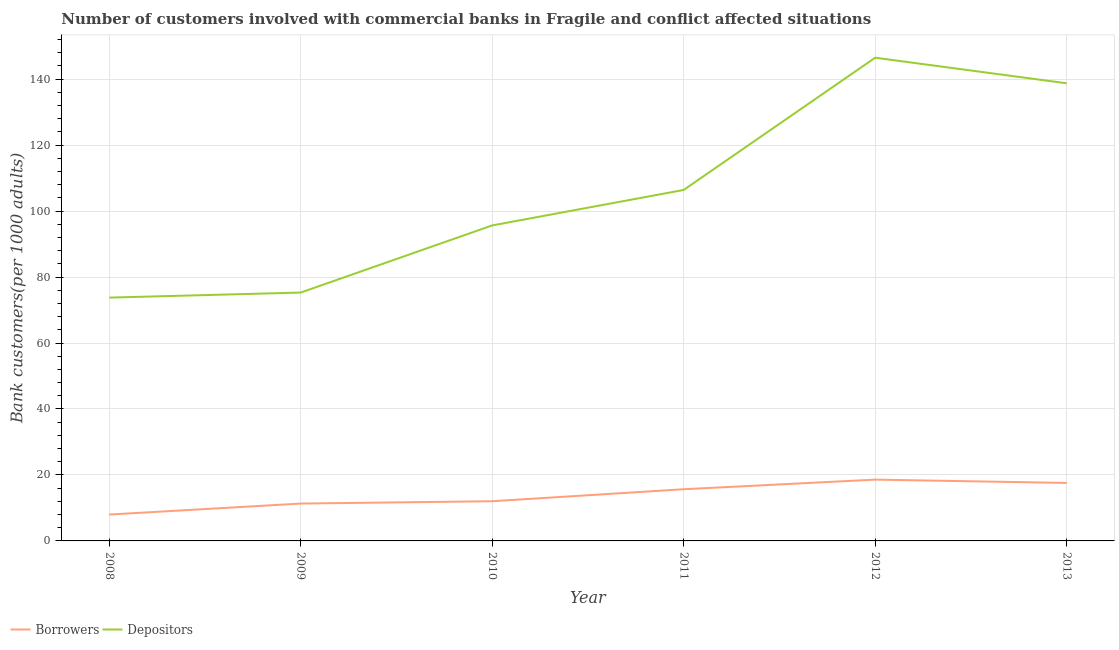How many different coloured lines are there?
Provide a short and direct response. 2. Does the line corresponding to number of borrowers intersect with the line corresponding to number of depositors?
Provide a short and direct response. No. Is the number of lines equal to the number of legend labels?
Your response must be concise. Yes. What is the number of depositors in 2011?
Your answer should be very brief. 106.41. Across all years, what is the maximum number of borrowers?
Provide a succinct answer. 18.58. Across all years, what is the minimum number of borrowers?
Make the answer very short. 7.99. In which year was the number of depositors minimum?
Make the answer very short. 2008. What is the total number of depositors in the graph?
Make the answer very short. 636.36. What is the difference between the number of borrowers in 2011 and that in 2013?
Ensure brevity in your answer.  -1.91. What is the difference between the number of borrowers in 2011 and the number of depositors in 2013?
Your answer should be compact. -123.07. What is the average number of depositors per year?
Offer a very short reply. 106.06. In the year 2013, what is the difference between the number of borrowers and number of depositors?
Your answer should be compact. -121.17. What is the ratio of the number of borrowers in 2012 to that in 2013?
Offer a very short reply. 1.06. Is the difference between the number of borrowers in 2009 and 2011 greater than the difference between the number of depositors in 2009 and 2011?
Offer a terse response. Yes. What is the difference between the highest and the second highest number of borrowers?
Your answer should be compact. 1. What is the difference between the highest and the lowest number of borrowers?
Offer a very short reply. 10.59. Is the sum of the number of depositors in 2008 and 2011 greater than the maximum number of borrowers across all years?
Keep it short and to the point. Yes. Is the number of borrowers strictly less than the number of depositors over the years?
Your answer should be very brief. Yes. How many years are there in the graph?
Offer a very short reply. 6. Does the graph contain any zero values?
Provide a succinct answer. No. Where does the legend appear in the graph?
Your answer should be very brief. Bottom left. How are the legend labels stacked?
Keep it short and to the point. Horizontal. What is the title of the graph?
Give a very brief answer. Number of customers involved with commercial banks in Fragile and conflict affected situations. What is the label or title of the X-axis?
Your answer should be very brief. Year. What is the label or title of the Y-axis?
Provide a succinct answer. Bank customers(per 1000 adults). What is the Bank customers(per 1000 adults) in Borrowers in 2008?
Your response must be concise. 7.99. What is the Bank customers(per 1000 adults) of Depositors in 2008?
Your answer should be very brief. 73.77. What is the Bank customers(per 1000 adults) in Borrowers in 2009?
Your answer should be compact. 11.33. What is the Bank customers(per 1000 adults) in Depositors in 2009?
Make the answer very short. 75.3. What is the Bank customers(per 1000 adults) of Borrowers in 2010?
Give a very brief answer. 12.03. What is the Bank customers(per 1000 adults) of Depositors in 2010?
Your answer should be very brief. 95.65. What is the Bank customers(per 1000 adults) in Borrowers in 2011?
Offer a terse response. 15.67. What is the Bank customers(per 1000 adults) of Depositors in 2011?
Make the answer very short. 106.41. What is the Bank customers(per 1000 adults) of Borrowers in 2012?
Your response must be concise. 18.58. What is the Bank customers(per 1000 adults) of Depositors in 2012?
Ensure brevity in your answer.  146.5. What is the Bank customers(per 1000 adults) of Borrowers in 2013?
Your answer should be very brief. 17.58. What is the Bank customers(per 1000 adults) of Depositors in 2013?
Keep it short and to the point. 138.74. Across all years, what is the maximum Bank customers(per 1000 adults) in Borrowers?
Your answer should be compact. 18.58. Across all years, what is the maximum Bank customers(per 1000 adults) in Depositors?
Offer a very short reply. 146.5. Across all years, what is the minimum Bank customers(per 1000 adults) in Borrowers?
Provide a short and direct response. 7.99. Across all years, what is the minimum Bank customers(per 1000 adults) in Depositors?
Give a very brief answer. 73.77. What is the total Bank customers(per 1000 adults) of Borrowers in the graph?
Provide a succinct answer. 83.18. What is the total Bank customers(per 1000 adults) of Depositors in the graph?
Keep it short and to the point. 636.36. What is the difference between the Bank customers(per 1000 adults) in Borrowers in 2008 and that in 2009?
Offer a terse response. -3.33. What is the difference between the Bank customers(per 1000 adults) in Depositors in 2008 and that in 2009?
Your answer should be compact. -1.53. What is the difference between the Bank customers(per 1000 adults) of Borrowers in 2008 and that in 2010?
Your response must be concise. -4.04. What is the difference between the Bank customers(per 1000 adults) of Depositors in 2008 and that in 2010?
Give a very brief answer. -21.88. What is the difference between the Bank customers(per 1000 adults) of Borrowers in 2008 and that in 2011?
Offer a terse response. -7.68. What is the difference between the Bank customers(per 1000 adults) in Depositors in 2008 and that in 2011?
Offer a very short reply. -32.64. What is the difference between the Bank customers(per 1000 adults) in Borrowers in 2008 and that in 2012?
Give a very brief answer. -10.59. What is the difference between the Bank customers(per 1000 adults) in Depositors in 2008 and that in 2012?
Your answer should be compact. -72.73. What is the difference between the Bank customers(per 1000 adults) of Borrowers in 2008 and that in 2013?
Offer a very short reply. -9.58. What is the difference between the Bank customers(per 1000 adults) in Depositors in 2008 and that in 2013?
Your answer should be compact. -64.97. What is the difference between the Bank customers(per 1000 adults) in Borrowers in 2009 and that in 2010?
Offer a very short reply. -0.7. What is the difference between the Bank customers(per 1000 adults) of Depositors in 2009 and that in 2010?
Provide a succinct answer. -20.35. What is the difference between the Bank customers(per 1000 adults) in Borrowers in 2009 and that in 2011?
Your answer should be compact. -4.34. What is the difference between the Bank customers(per 1000 adults) of Depositors in 2009 and that in 2011?
Your response must be concise. -31.11. What is the difference between the Bank customers(per 1000 adults) in Borrowers in 2009 and that in 2012?
Provide a short and direct response. -7.25. What is the difference between the Bank customers(per 1000 adults) in Depositors in 2009 and that in 2012?
Make the answer very short. -71.2. What is the difference between the Bank customers(per 1000 adults) in Borrowers in 2009 and that in 2013?
Provide a succinct answer. -6.25. What is the difference between the Bank customers(per 1000 adults) of Depositors in 2009 and that in 2013?
Keep it short and to the point. -63.44. What is the difference between the Bank customers(per 1000 adults) in Borrowers in 2010 and that in 2011?
Offer a terse response. -3.64. What is the difference between the Bank customers(per 1000 adults) of Depositors in 2010 and that in 2011?
Provide a short and direct response. -10.75. What is the difference between the Bank customers(per 1000 adults) in Borrowers in 2010 and that in 2012?
Provide a succinct answer. -6.55. What is the difference between the Bank customers(per 1000 adults) of Depositors in 2010 and that in 2012?
Ensure brevity in your answer.  -50.84. What is the difference between the Bank customers(per 1000 adults) in Borrowers in 2010 and that in 2013?
Your response must be concise. -5.55. What is the difference between the Bank customers(per 1000 adults) in Depositors in 2010 and that in 2013?
Keep it short and to the point. -43.09. What is the difference between the Bank customers(per 1000 adults) in Borrowers in 2011 and that in 2012?
Ensure brevity in your answer.  -2.91. What is the difference between the Bank customers(per 1000 adults) in Depositors in 2011 and that in 2012?
Provide a succinct answer. -40.09. What is the difference between the Bank customers(per 1000 adults) of Borrowers in 2011 and that in 2013?
Ensure brevity in your answer.  -1.91. What is the difference between the Bank customers(per 1000 adults) of Depositors in 2011 and that in 2013?
Your answer should be compact. -32.34. What is the difference between the Bank customers(per 1000 adults) of Borrowers in 2012 and that in 2013?
Offer a very short reply. 1. What is the difference between the Bank customers(per 1000 adults) in Depositors in 2012 and that in 2013?
Offer a very short reply. 7.75. What is the difference between the Bank customers(per 1000 adults) of Borrowers in 2008 and the Bank customers(per 1000 adults) of Depositors in 2009?
Your response must be concise. -67.31. What is the difference between the Bank customers(per 1000 adults) of Borrowers in 2008 and the Bank customers(per 1000 adults) of Depositors in 2010?
Your response must be concise. -87.66. What is the difference between the Bank customers(per 1000 adults) in Borrowers in 2008 and the Bank customers(per 1000 adults) in Depositors in 2011?
Your answer should be very brief. -98.41. What is the difference between the Bank customers(per 1000 adults) of Borrowers in 2008 and the Bank customers(per 1000 adults) of Depositors in 2012?
Your answer should be compact. -138.5. What is the difference between the Bank customers(per 1000 adults) of Borrowers in 2008 and the Bank customers(per 1000 adults) of Depositors in 2013?
Offer a very short reply. -130.75. What is the difference between the Bank customers(per 1000 adults) in Borrowers in 2009 and the Bank customers(per 1000 adults) in Depositors in 2010?
Your answer should be compact. -84.32. What is the difference between the Bank customers(per 1000 adults) of Borrowers in 2009 and the Bank customers(per 1000 adults) of Depositors in 2011?
Provide a succinct answer. -95.08. What is the difference between the Bank customers(per 1000 adults) in Borrowers in 2009 and the Bank customers(per 1000 adults) in Depositors in 2012?
Offer a terse response. -135.17. What is the difference between the Bank customers(per 1000 adults) of Borrowers in 2009 and the Bank customers(per 1000 adults) of Depositors in 2013?
Your response must be concise. -127.41. What is the difference between the Bank customers(per 1000 adults) of Borrowers in 2010 and the Bank customers(per 1000 adults) of Depositors in 2011?
Your response must be concise. -94.37. What is the difference between the Bank customers(per 1000 adults) in Borrowers in 2010 and the Bank customers(per 1000 adults) in Depositors in 2012?
Ensure brevity in your answer.  -134.46. What is the difference between the Bank customers(per 1000 adults) in Borrowers in 2010 and the Bank customers(per 1000 adults) in Depositors in 2013?
Make the answer very short. -126.71. What is the difference between the Bank customers(per 1000 adults) in Borrowers in 2011 and the Bank customers(per 1000 adults) in Depositors in 2012?
Offer a terse response. -130.83. What is the difference between the Bank customers(per 1000 adults) in Borrowers in 2011 and the Bank customers(per 1000 adults) in Depositors in 2013?
Your answer should be very brief. -123.07. What is the difference between the Bank customers(per 1000 adults) of Borrowers in 2012 and the Bank customers(per 1000 adults) of Depositors in 2013?
Provide a short and direct response. -120.16. What is the average Bank customers(per 1000 adults) of Borrowers per year?
Make the answer very short. 13.86. What is the average Bank customers(per 1000 adults) of Depositors per year?
Keep it short and to the point. 106.06. In the year 2008, what is the difference between the Bank customers(per 1000 adults) in Borrowers and Bank customers(per 1000 adults) in Depositors?
Provide a succinct answer. -65.77. In the year 2009, what is the difference between the Bank customers(per 1000 adults) in Borrowers and Bank customers(per 1000 adults) in Depositors?
Keep it short and to the point. -63.97. In the year 2010, what is the difference between the Bank customers(per 1000 adults) in Borrowers and Bank customers(per 1000 adults) in Depositors?
Your answer should be very brief. -83.62. In the year 2011, what is the difference between the Bank customers(per 1000 adults) of Borrowers and Bank customers(per 1000 adults) of Depositors?
Provide a short and direct response. -90.74. In the year 2012, what is the difference between the Bank customers(per 1000 adults) in Borrowers and Bank customers(per 1000 adults) in Depositors?
Your answer should be compact. -127.91. In the year 2013, what is the difference between the Bank customers(per 1000 adults) in Borrowers and Bank customers(per 1000 adults) in Depositors?
Offer a very short reply. -121.17. What is the ratio of the Bank customers(per 1000 adults) in Borrowers in 2008 to that in 2009?
Keep it short and to the point. 0.71. What is the ratio of the Bank customers(per 1000 adults) in Depositors in 2008 to that in 2009?
Your answer should be compact. 0.98. What is the ratio of the Bank customers(per 1000 adults) of Borrowers in 2008 to that in 2010?
Keep it short and to the point. 0.66. What is the ratio of the Bank customers(per 1000 adults) of Depositors in 2008 to that in 2010?
Offer a terse response. 0.77. What is the ratio of the Bank customers(per 1000 adults) of Borrowers in 2008 to that in 2011?
Make the answer very short. 0.51. What is the ratio of the Bank customers(per 1000 adults) in Depositors in 2008 to that in 2011?
Provide a succinct answer. 0.69. What is the ratio of the Bank customers(per 1000 adults) in Borrowers in 2008 to that in 2012?
Give a very brief answer. 0.43. What is the ratio of the Bank customers(per 1000 adults) of Depositors in 2008 to that in 2012?
Provide a short and direct response. 0.5. What is the ratio of the Bank customers(per 1000 adults) of Borrowers in 2008 to that in 2013?
Ensure brevity in your answer.  0.45. What is the ratio of the Bank customers(per 1000 adults) in Depositors in 2008 to that in 2013?
Offer a very short reply. 0.53. What is the ratio of the Bank customers(per 1000 adults) of Borrowers in 2009 to that in 2010?
Your answer should be compact. 0.94. What is the ratio of the Bank customers(per 1000 adults) in Depositors in 2009 to that in 2010?
Offer a terse response. 0.79. What is the ratio of the Bank customers(per 1000 adults) of Borrowers in 2009 to that in 2011?
Give a very brief answer. 0.72. What is the ratio of the Bank customers(per 1000 adults) of Depositors in 2009 to that in 2011?
Give a very brief answer. 0.71. What is the ratio of the Bank customers(per 1000 adults) in Borrowers in 2009 to that in 2012?
Give a very brief answer. 0.61. What is the ratio of the Bank customers(per 1000 adults) in Depositors in 2009 to that in 2012?
Keep it short and to the point. 0.51. What is the ratio of the Bank customers(per 1000 adults) of Borrowers in 2009 to that in 2013?
Ensure brevity in your answer.  0.64. What is the ratio of the Bank customers(per 1000 adults) of Depositors in 2009 to that in 2013?
Offer a very short reply. 0.54. What is the ratio of the Bank customers(per 1000 adults) of Borrowers in 2010 to that in 2011?
Make the answer very short. 0.77. What is the ratio of the Bank customers(per 1000 adults) of Depositors in 2010 to that in 2011?
Give a very brief answer. 0.9. What is the ratio of the Bank customers(per 1000 adults) of Borrowers in 2010 to that in 2012?
Provide a short and direct response. 0.65. What is the ratio of the Bank customers(per 1000 adults) of Depositors in 2010 to that in 2012?
Offer a terse response. 0.65. What is the ratio of the Bank customers(per 1000 adults) in Borrowers in 2010 to that in 2013?
Offer a very short reply. 0.68. What is the ratio of the Bank customers(per 1000 adults) in Depositors in 2010 to that in 2013?
Ensure brevity in your answer.  0.69. What is the ratio of the Bank customers(per 1000 adults) of Borrowers in 2011 to that in 2012?
Provide a succinct answer. 0.84. What is the ratio of the Bank customers(per 1000 adults) in Depositors in 2011 to that in 2012?
Make the answer very short. 0.73. What is the ratio of the Bank customers(per 1000 adults) of Borrowers in 2011 to that in 2013?
Offer a very short reply. 0.89. What is the ratio of the Bank customers(per 1000 adults) in Depositors in 2011 to that in 2013?
Ensure brevity in your answer.  0.77. What is the ratio of the Bank customers(per 1000 adults) in Borrowers in 2012 to that in 2013?
Give a very brief answer. 1.06. What is the ratio of the Bank customers(per 1000 adults) of Depositors in 2012 to that in 2013?
Make the answer very short. 1.06. What is the difference between the highest and the second highest Bank customers(per 1000 adults) in Depositors?
Give a very brief answer. 7.75. What is the difference between the highest and the lowest Bank customers(per 1000 adults) in Borrowers?
Offer a terse response. 10.59. What is the difference between the highest and the lowest Bank customers(per 1000 adults) in Depositors?
Give a very brief answer. 72.73. 